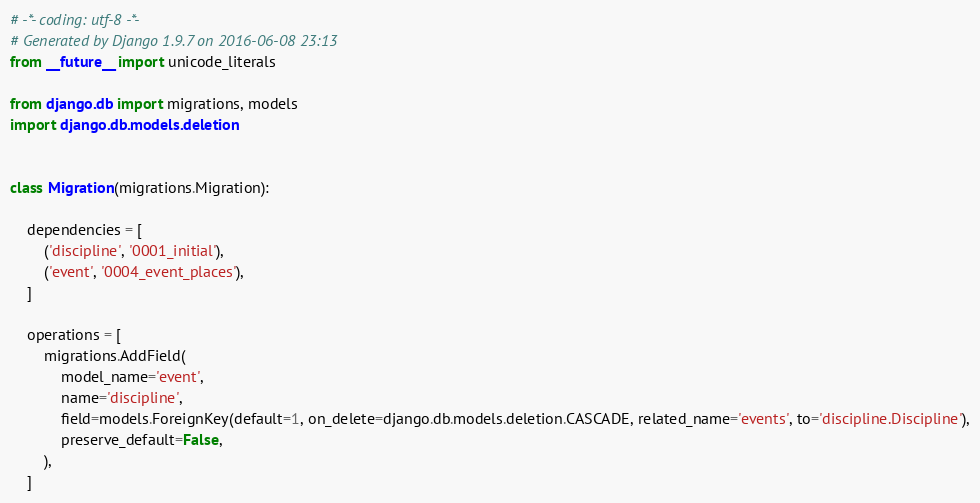Convert code to text. <code><loc_0><loc_0><loc_500><loc_500><_Python_># -*- coding: utf-8 -*-
# Generated by Django 1.9.7 on 2016-06-08 23:13
from __future__ import unicode_literals

from django.db import migrations, models
import django.db.models.deletion


class Migration(migrations.Migration):

    dependencies = [
        ('discipline', '0001_initial'),
        ('event', '0004_event_places'),
    ]

    operations = [
        migrations.AddField(
            model_name='event',
            name='discipline',
            field=models.ForeignKey(default=1, on_delete=django.db.models.deletion.CASCADE, related_name='events', to='discipline.Discipline'),
            preserve_default=False,
        ),
    ]
</code> 